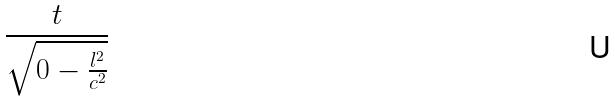<formula> <loc_0><loc_0><loc_500><loc_500>\frac { t } { \sqrt { 0 - \frac { l ^ { 2 } } { c ^ { 2 } } } }</formula> 